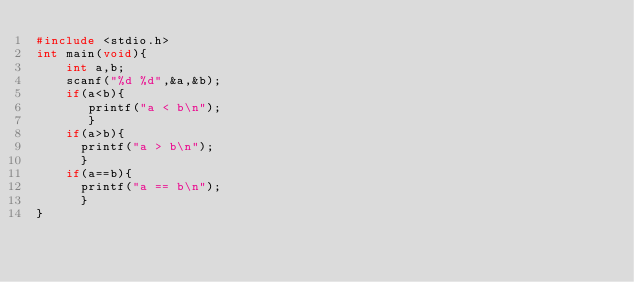<code> <loc_0><loc_0><loc_500><loc_500><_C_>#include <stdio.h>
int main(void){
    int a,b;
    scanf("%d %d",&a,&b);
    if(a<b){
       printf("a < b\n");
       }
    if(a>b){
      printf("a > b\n");
      }
    if(a==b){
      printf("a == b\n");
      }
}</code> 